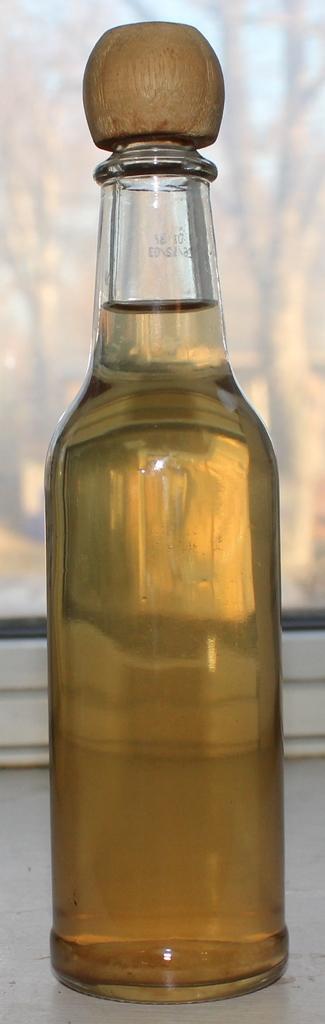Please provide a concise description of this image. In center we can see the bottle,some liquid into it. 